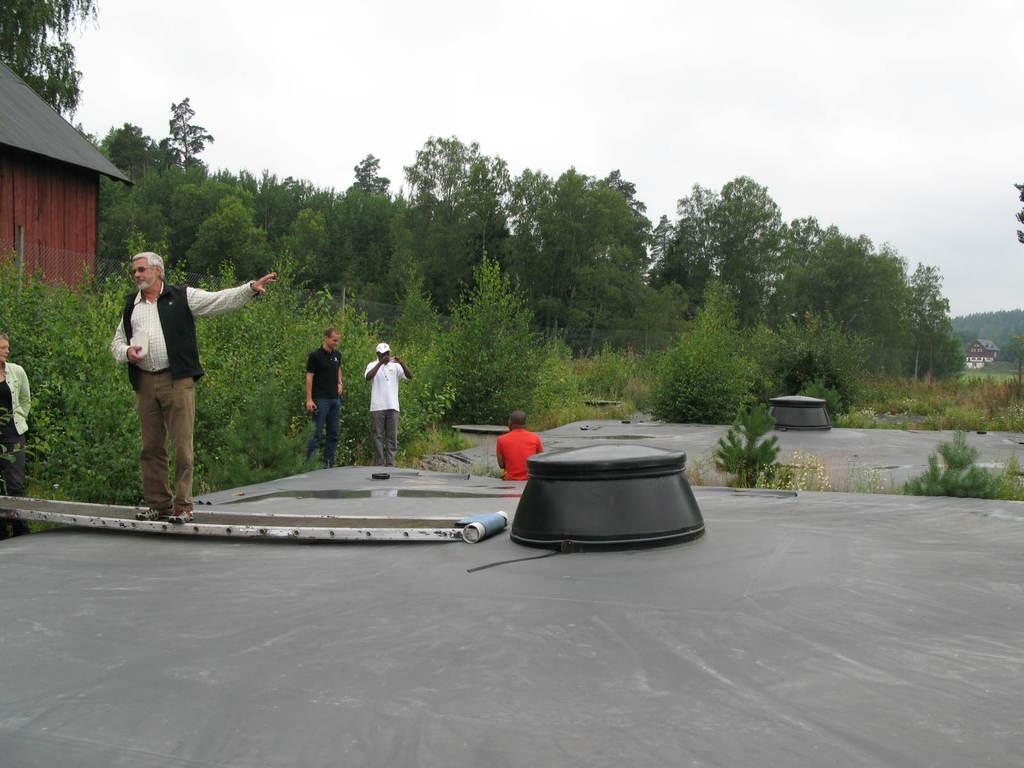Can you describe this image briefly? In the image we can see there are four people standing and one is sitting, they are wearing clothes and shoes. This person is wearing goggles and another person is wearing a cap. This is a footpath, object, grass, plants, trees and a white sky. This is a house. 